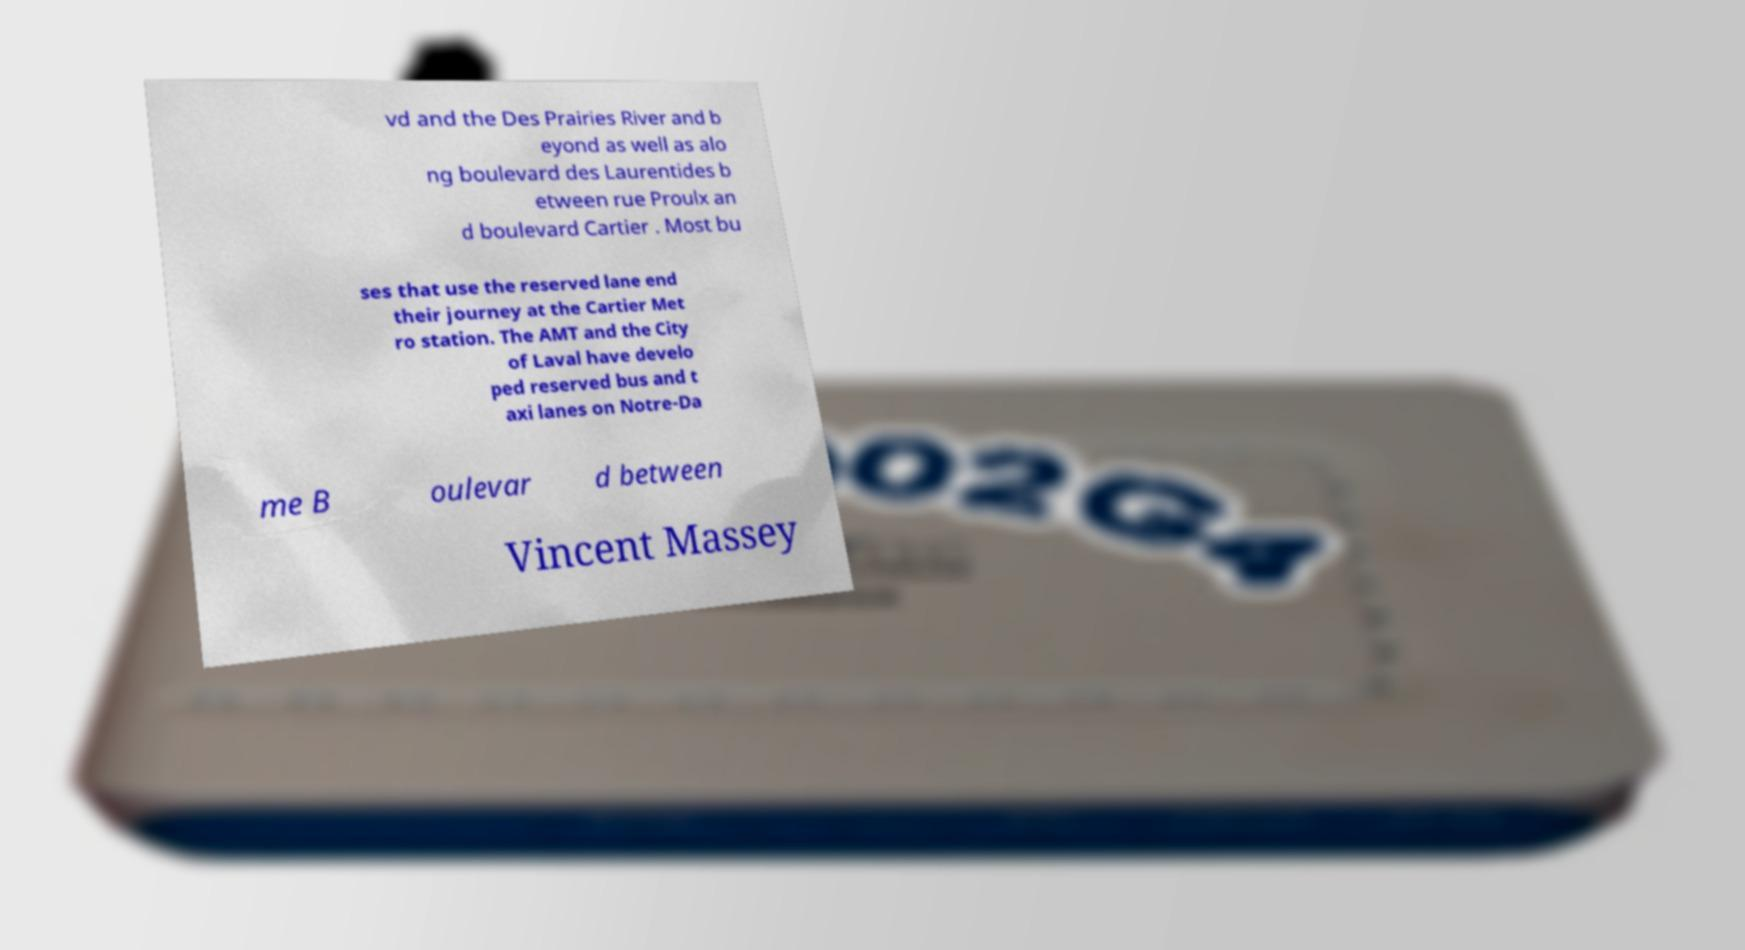I need the written content from this picture converted into text. Can you do that? vd and the Des Prairies River and b eyond as well as alo ng boulevard des Laurentides b etween rue Proulx an d boulevard Cartier . Most bu ses that use the reserved lane end their journey at the Cartier Met ro station. The AMT and the City of Laval have develo ped reserved bus and t axi lanes on Notre-Da me B oulevar d between Vincent Massey 